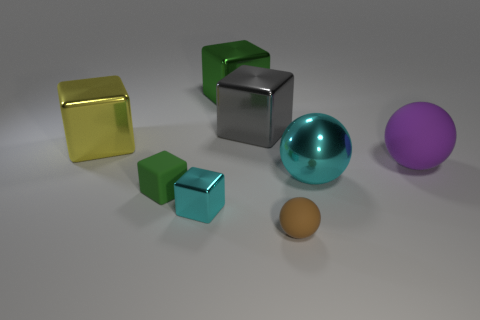Add 1 gray metal blocks. How many objects exist? 9 Subtract all large yellow metal blocks. How many blocks are left? 4 Subtract 2 cubes. How many cubes are left? 3 Subtract all cyan cubes. How many cubes are left? 4 Subtract all cubes. How many objects are left? 3 Subtract all objects. Subtract all red matte cylinders. How many objects are left? 0 Add 4 large green metal things. How many large green metal things are left? 5 Add 1 large matte spheres. How many large matte spheres exist? 2 Subtract 0 blue blocks. How many objects are left? 8 Subtract all gray spheres. Subtract all blue cylinders. How many spheres are left? 3 